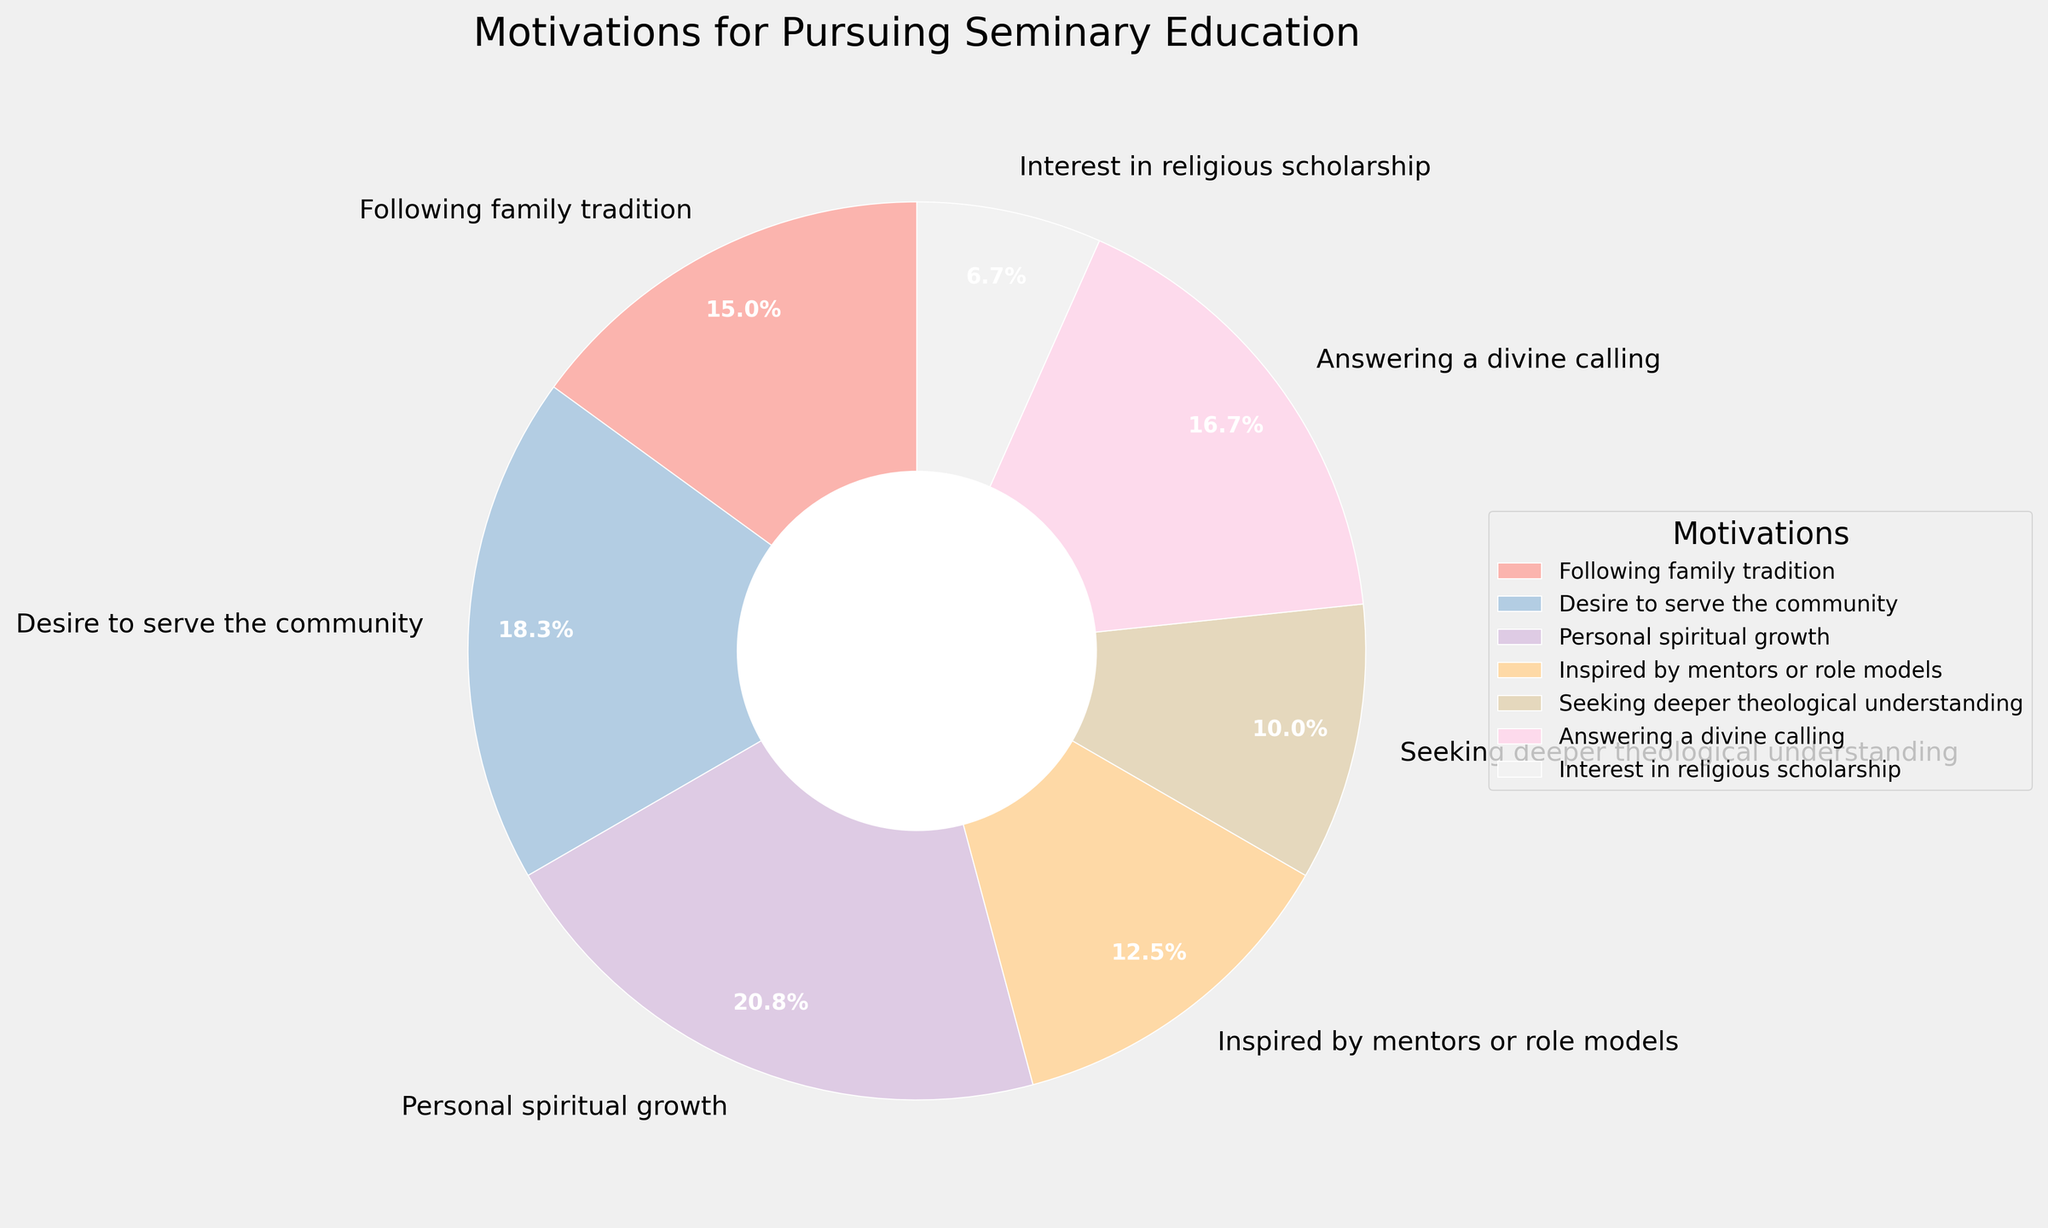What percentage of people pursue seminary education because of a desire for personal spiritual growth? According to the pie chart, the section labeled "Personal spiritual growth" represents 25% of the total motivations.
Answer: 25% Which motivation has a greater percentage: answering a divine calling or following family tradition? The pie chart shows that answering a divine calling has a percentage of 20%, while following family tradition has a percentage of 18%. Therefore, answering a divine calling has a greater percentage.
Answer: Answering a divine calling What is the combined percentage of people motivated by a desire to serve the community and those inspired by mentors or role models? The pie chart indicates that the percentage for a desire to serve the community is 22%, and for being inspired by mentors or role models, it is 15%. Adding these together gives 22% + 15% = 37%.
Answer: 37% Which motivation has the smallest representation, and what is its percentage? From the pie chart, the smallest section is labeled "Interest in religious scholarship," which has a percentage of 8%.
Answer: Interest in religious scholarship, 8% Is the percentage of people who are motivated by seeking deeper theological understanding greater or less than those inspired by mentors or role models? The pie chart shows that seeking deeper theological understanding accounts for 12%, and being inspired by mentors or role models accounts for 15%. Therefore, the percentage for seeking deeper theological understanding is less.
Answer: Less What is the total percentage of people motivated by either a desire to serve the community, personal spiritual growth, or answering a divine calling? The pie chart provides these percentages: desire to serve the community (22%), personal spiritual growth (25%), and answering a divine calling (20%). Summing them up: 22% + 25% + 20% = 67%.
Answer: 67% What is the difference in percentage between people who follow family tradition and those who seek deeper theological understanding? The pie chart shows that following family tradition accounts for 18%, while seeking deeper theological understanding is 12%. The difference is 18% - 12% = 6%.
Answer: 6% Which motivation has more representation: a desire to serve the community or personal spiritual growth, and by how much? Personal spiritual growth has a percentage of 25%, and a desire to serve the community has 22%. The difference is 25% - 22% = 3%.
Answer: Personal spiritual growth, 3% How does the "Inspired by mentors or role models" percentage compare to the "Interest in religious scholarship" percentage? The pie chart indicates that "Inspired by mentors or role models" is 15%, while "Interest in religious scholarship" is 8%. Thus, the former is nearly twice as much.
Answer: Nearly twice as much 